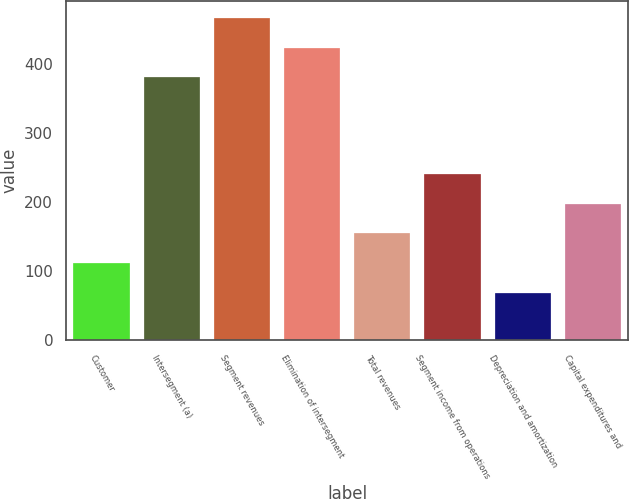<chart> <loc_0><loc_0><loc_500><loc_500><bar_chart><fcel>Customer<fcel>Intersegment (a)<fcel>Segment revenues<fcel>Elimination of intersegment<fcel>Total revenues<fcel>Segment income from operations<fcel>Depreciation and amortization<fcel>Capital expenditures and<nl><fcel>111<fcel>381<fcel>468<fcel>424.5<fcel>154.5<fcel>241.5<fcel>67.5<fcel>198<nl></chart> 